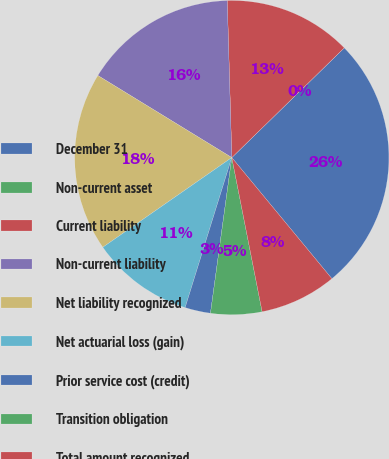Convert chart to OTSL. <chart><loc_0><loc_0><loc_500><loc_500><pie_chart><fcel>December 31<fcel>Non-current asset<fcel>Current liability<fcel>Non-current liability<fcel>Net liability recognized<fcel>Net actuarial loss (gain)<fcel>Prior service cost (credit)<fcel>Transition obligation<fcel>Total amount recognized<nl><fcel>26.31%<fcel>0.0%<fcel>13.16%<fcel>15.79%<fcel>18.42%<fcel>10.53%<fcel>2.63%<fcel>5.26%<fcel>7.9%<nl></chart> 